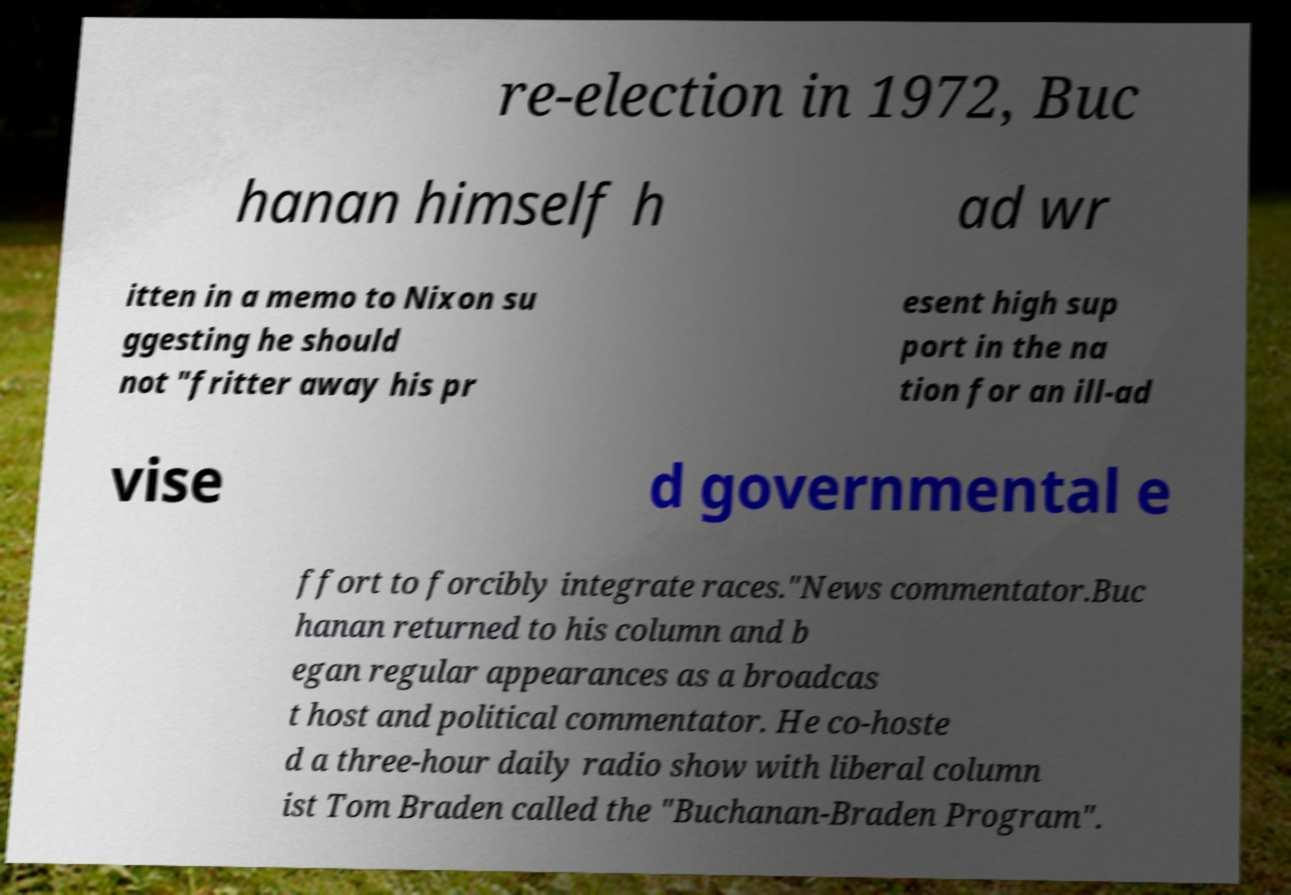Could you assist in decoding the text presented in this image and type it out clearly? re-election in 1972, Buc hanan himself h ad wr itten in a memo to Nixon su ggesting he should not "fritter away his pr esent high sup port in the na tion for an ill-ad vise d governmental e ffort to forcibly integrate races."News commentator.Buc hanan returned to his column and b egan regular appearances as a broadcas t host and political commentator. He co-hoste d a three-hour daily radio show with liberal column ist Tom Braden called the "Buchanan-Braden Program". 